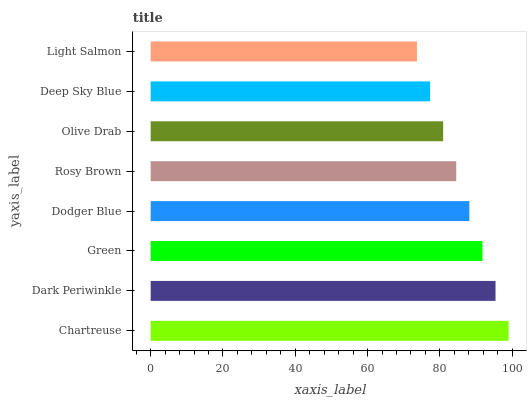Is Light Salmon the minimum?
Answer yes or no. Yes. Is Chartreuse the maximum?
Answer yes or no. Yes. Is Dark Periwinkle the minimum?
Answer yes or no. No. Is Dark Periwinkle the maximum?
Answer yes or no. No. Is Chartreuse greater than Dark Periwinkle?
Answer yes or no. Yes. Is Dark Periwinkle less than Chartreuse?
Answer yes or no. Yes. Is Dark Periwinkle greater than Chartreuse?
Answer yes or no. No. Is Chartreuse less than Dark Periwinkle?
Answer yes or no. No. Is Dodger Blue the high median?
Answer yes or no. Yes. Is Rosy Brown the low median?
Answer yes or no. Yes. Is Olive Drab the high median?
Answer yes or no. No. Is Dark Periwinkle the low median?
Answer yes or no. No. 